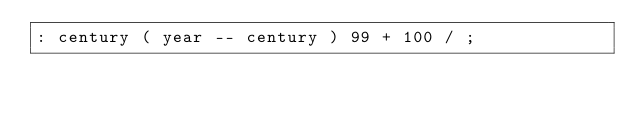Convert code to text. <code><loc_0><loc_0><loc_500><loc_500><_Forth_>: century ( year -- century ) 99 + 100 / ;</code> 